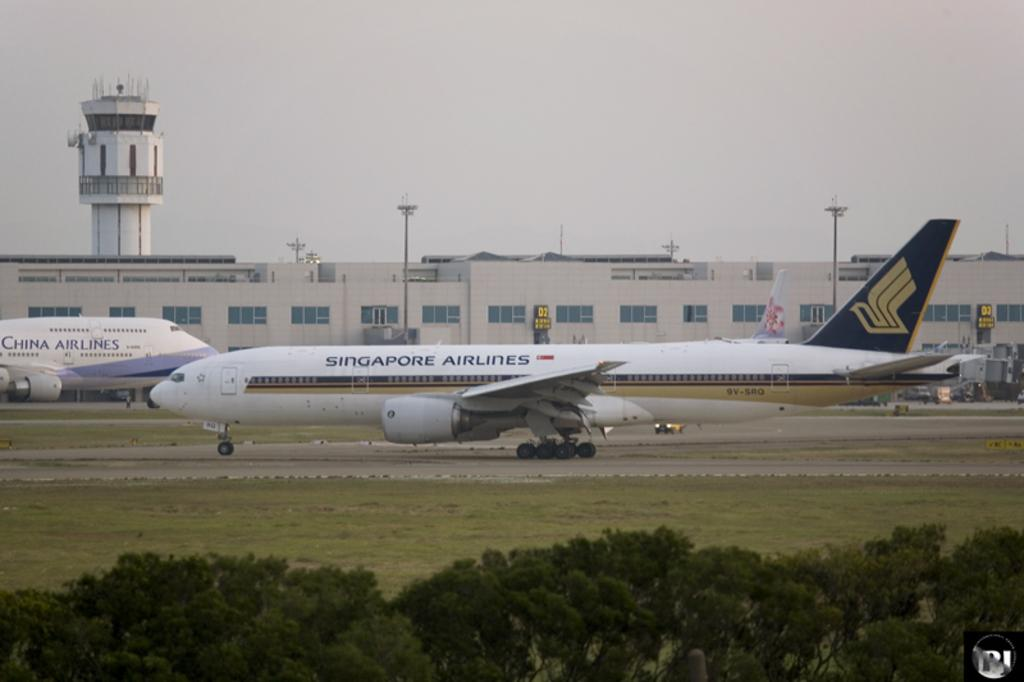<image>
Offer a succinct explanation of the picture presented. A white Singapore Airlines passenger jet is taxiing on a runway. 